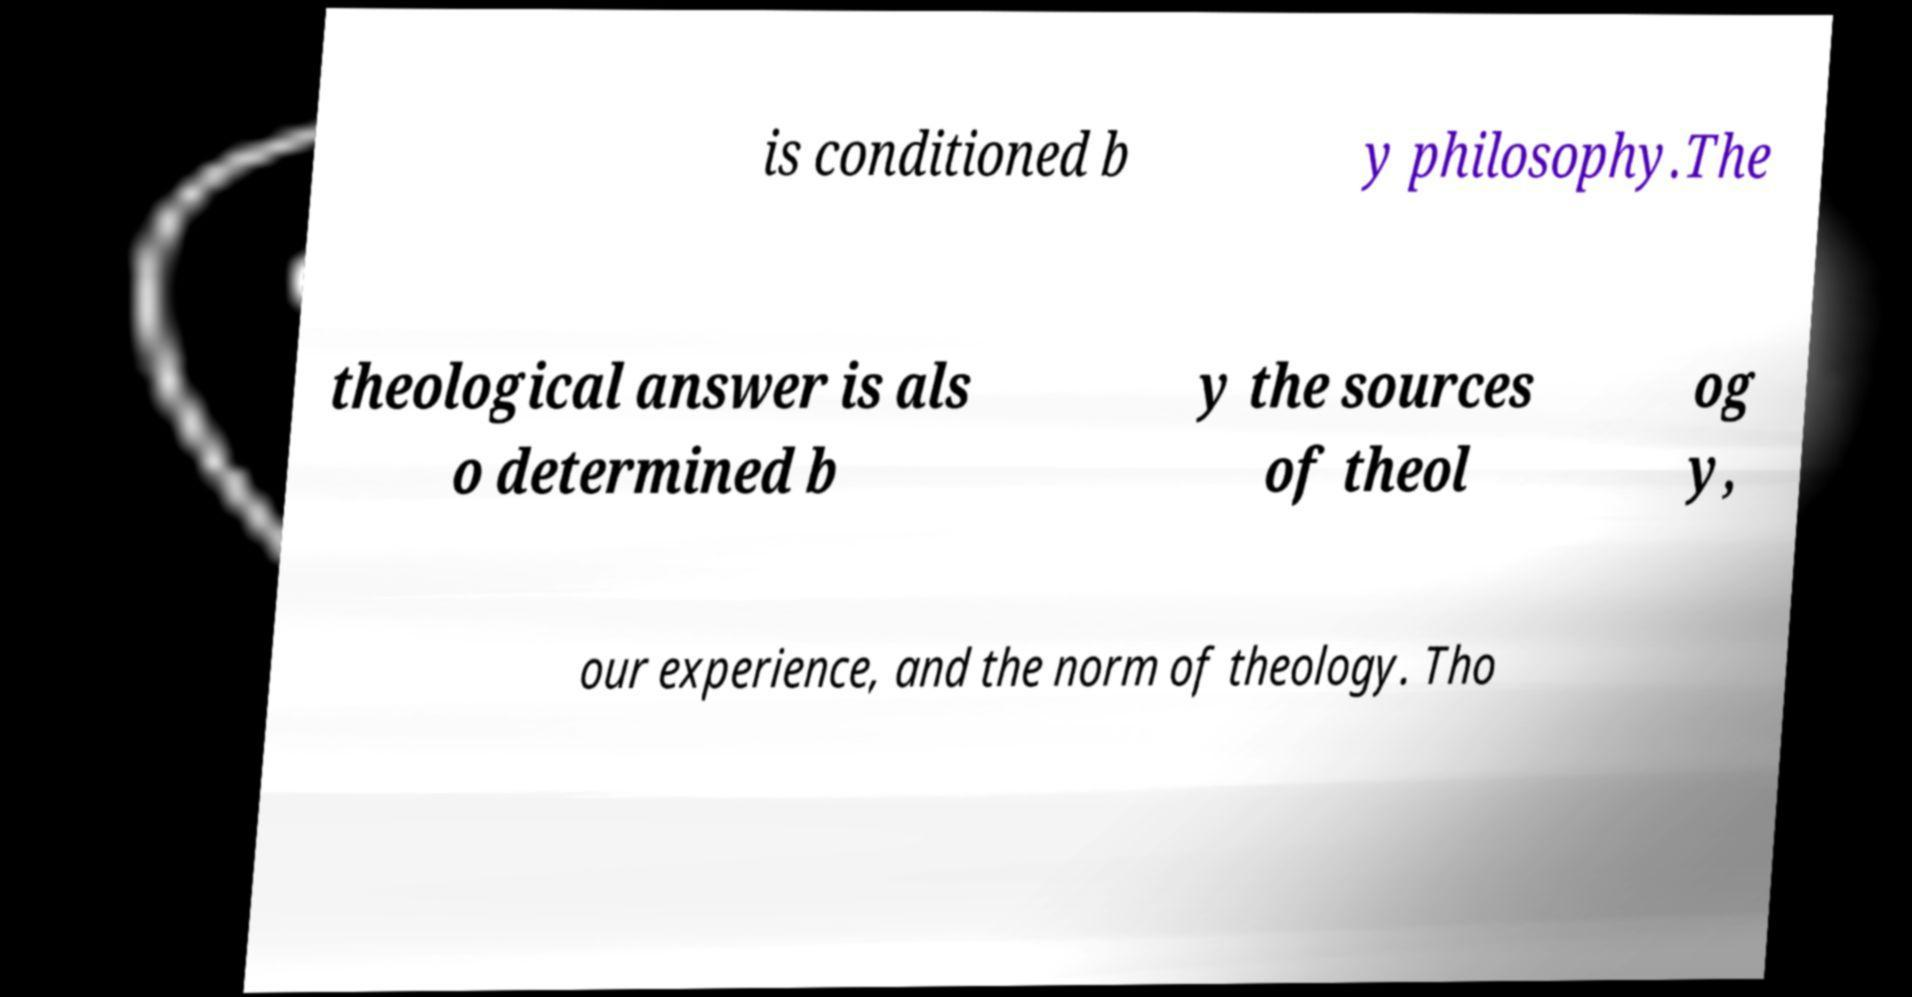Could you assist in decoding the text presented in this image and type it out clearly? is conditioned b y philosophy.The theological answer is als o determined b y the sources of theol og y, our experience, and the norm of theology. Tho 